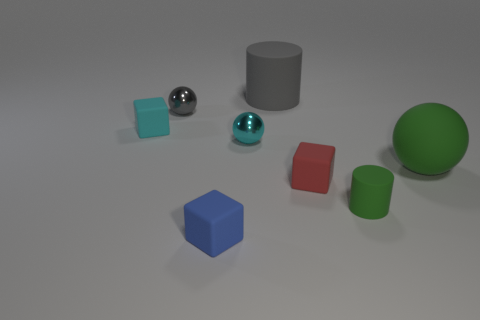Do the small cube that is right of the big gray matte cylinder and the small matte cylinder have the same color?
Your answer should be very brief. No. Do the red cube and the gray thing that is in front of the large gray cylinder have the same material?
Provide a short and direct response. No. There is a large matte thing to the right of the gray cylinder; what shape is it?
Give a very brief answer. Sphere. How many other objects are the same material as the blue thing?
Offer a terse response. 5. The gray matte thing has what size?
Make the answer very short. Large. How many other things are there of the same color as the small matte cylinder?
Give a very brief answer. 1. What color is the small cube that is left of the cyan metallic object and on the right side of the gray metallic sphere?
Your response must be concise. Blue. How many big spheres are there?
Your answer should be compact. 1. Does the large gray thing have the same material as the tiny red block?
Provide a succinct answer. Yes. There is a big matte thing that is to the right of the green object that is left of the rubber thing to the right of the green rubber cylinder; what is its shape?
Provide a short and direct response. Sphere. 